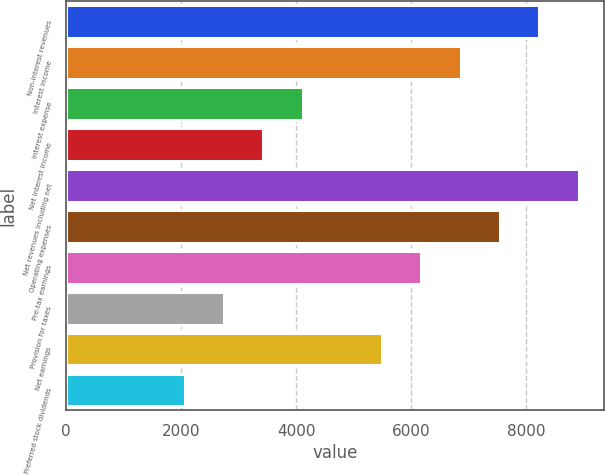Convert chart. <chart><loc_0><loc_0><loc_500><loc_500><bar_chart><fcel>Non-interest revenues<fcel>Interest income<fcel>Interest expense<fcel>Net interest income<fcel>Net revenues including net<fcel>Operating expenses<fcel>Pre-tax earnings<fcel>Provision for taxes<fcel>Net earnings<fcel>Preferred stock dividends<nl><fcel>8233.12<fcel>6861.05<fcel>4116.89<fcel>3430.85<fcel>8919.16<fcel>7547.09<fcel>6175.01<fcel>2744.81<fcel>5488.97<fcel>2058.77<nl></chart> 